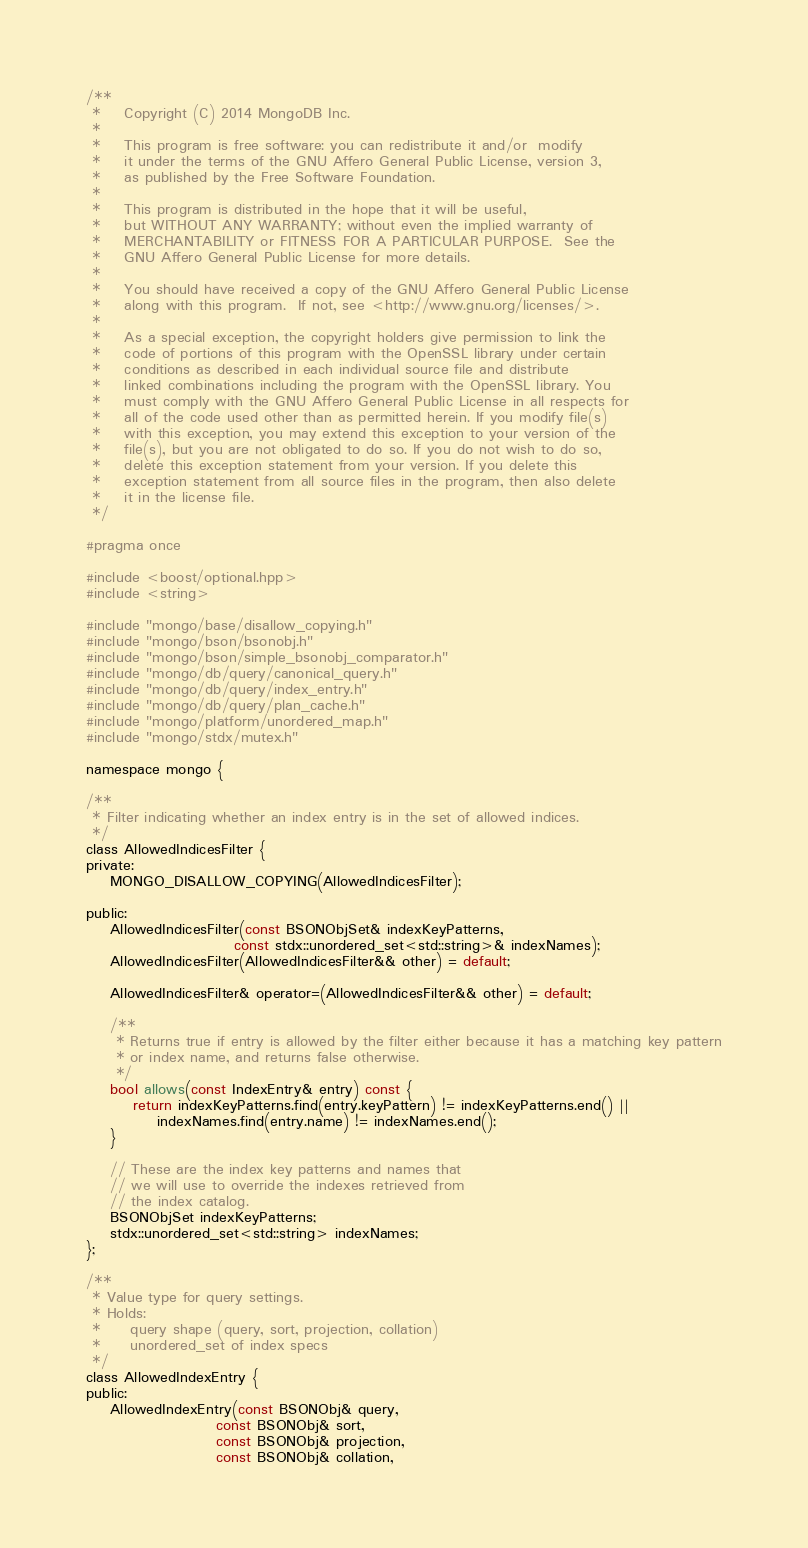Convert code to text. <code><loc_0><loc_0><loc_500><loc_500><_C_>/**
 *    Copyright (C) 2014 MongoDB Inc.
 *
 *    This program is free software: you can redistribute it and/or  modify
 *    it under the terms of the GNU Affero General Public License, version 3,
 *    as published by the Free Software Foundation.
 *
 *    This program is distributed in the hope that it will be useful,
 *    but WITHOUT ANY WARRANTY; without even the implied warranty of
 *    MERCHANTABILITY or FITNESS FOR A PARTICULAR PURPOSE.  See the
 *    GNU Affero General Public License for more details.
 *
 *    You should have received a copy of the GNU Affero General Public License
 *    along with this program.  If not, see <http://www.gnu.org/licenses/>.
 *
 *    As a special exception, the copyright holders give permission to link the
 *    code of portions of this program with the OpenSSL library under certain
 *    conditions as described in each individual source file and distribute
 *    linked combinations including the program with the OpenSSL library. You
 *    must comply with the GNU Affero General Public License in all respects for
 *    all of the code used other than as permitted herein. If you modify file(s)
 *    with this exception, you may extend this exception to your version of the
 *    file(s), but you are not obligated to do so. If you do not wish to do so,
 *    delete this exception statement from your version. If you delete this
 *    exception statement from all source files in the program, then also delete
 *    it in the license file.
 */

#pragma once

#include <boost/optional.hpp>
#include <string>

#include "mongo/base/disallow_copying.h"
#include "mongo/bson/bsonobj.h"
#include "mongo/bson/simple_bsonobj_comparator.h"
#include "mongo/db/query/canonical_query.h"
#include "mongo/db/query/index_entry.h"
#include "mongo/db/query/plan_cache.h"
#include "mongo/platform/unordered_map.h"
#include "mongo/stdx/mutex.h"

namespace mongo {

/**
 * Filter indicating whether an index entry is in the set of allowed indices.
 */
class AllowedIndicesFilter {
private:
    MONGO_DISALLOW_COPYING(AllowedIndicesFilter);

public:
    AllowedIndicesFilter(const BSONObjSet& indexKeyPatterns,
                         const stdx::unordered_set<std::string>& indexNames);
    AllowedIndicesFilter(AllowedIndicesFilter&& other) = default;

    AllowedIndicesFilter& operator=(AllowedIndicesFilter&& other) = default;

    /**
     * Returns true if entry is allowed by the filter either because it has a matching key pattern
     * or index name, and returns false otherwise.
     */
    bool allows(const IndexEntry& entry) const {
        return indexKeyPatterns.find(entry.keyPattern) != indexKeyPatterns.end() ||
            indexNames.find(entry.name) != indexNames.end();
    }

    // These are the index key patterns and names that
    // we will use to override the indexes retrieved from
    // the index catalog.
    BSONObjSet indexKeyPatterns;
    stdx::unordered_set<std::string> indexNames;
};

/**
 * Value type for query settings.
 * Holds:
 *     query shape (query, sort, projection, collation)
 *     unordered_set of index specs
 */
class AllowedIndexEntry {
public:
    AllowedIndexEntry(const BSONObj& query,
                      const BSONObj& sort,
                      const BSONObj& projection,
                      const BSONObj& collation,</code> 